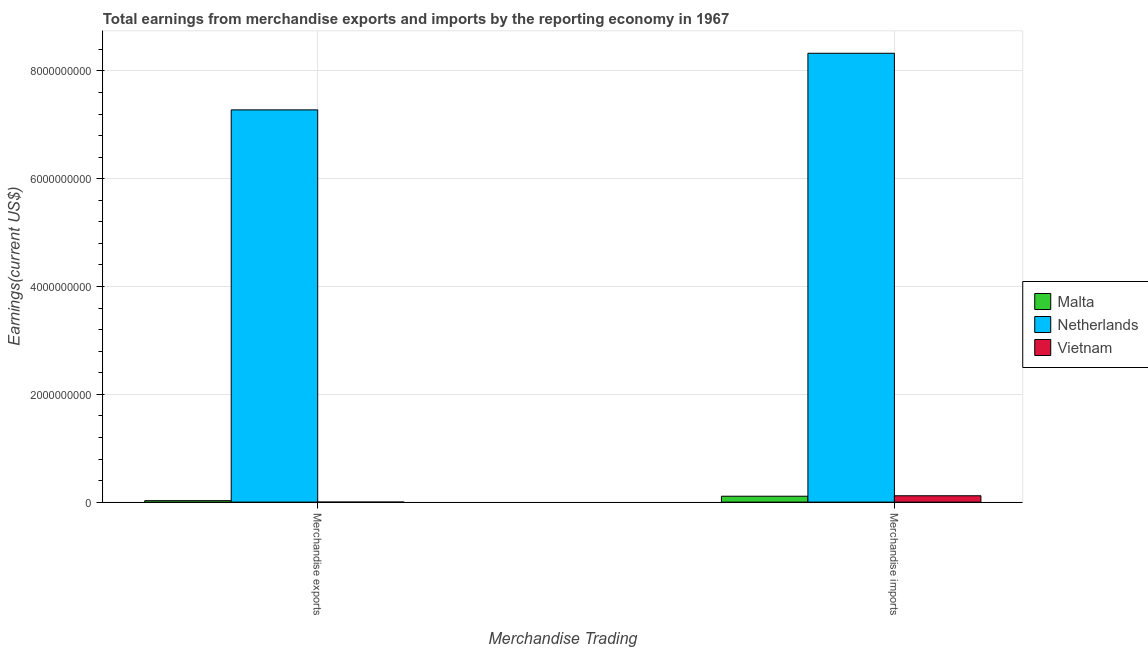How many different coloured bars are there?
Provide a short and direct response. 3. How many groups of bars are there?
Offer a very short reply. 2. Are the number of bars per tick equal to the number of legend labels?
Offer a terse response. Yes. How many bars are there on the 2nd tick from the left?
Keep it short and to the point. 3. What is the earnings from merchandise imports in Vietnam?
Give a very brief answer. 1.18e+08. Across all countries, what is the maximum earnings from merchandise exports?
Offer a very short reply. 7.28e+09. Across all countries, what is the minimum earnings from merchandise imports?
Make the answer very short. 1.10e+08. In which country was the earnings from merchandise imports maximum?
Your answer should be very brief. Netherlands. In which country was the earnings from merchandise imports minimum?
Provide a short and direct response. Malta. What is the total earnings from merchandise exports in the graph?
Keep it short and to the point. 7.31e+09. What is the difference between the earnings from merchandise exports in Malta and that in Netherlands?
Keep it short and to the point. -7.25e+09. What is the difference between the earnings from merchandise exports in Malta and the earnings from merchandise imports in Vietnam?
Provide a short and direct response. -9.09e+07. What is the average earnings from merchandise exports per country?
Provide a succinct answer. 2.44e+09. What is the difference between the earnings from merchandise exports and earnings from merchandise imports in Netherlands?
Your response must be concise. -1.05e+09. What is the ratio of the earnings from merchandise exports in Vietnam to that in Malta?
Your answer should be compact. 0.01. In how many countries, is the earnings from merchandise imports greater than the average earnings from merchandise imports taken over all countries?
Offer a terse response. 1. What does the 3rd bar from the left in Merchandise imports represents?
Ensure brevity in your answer.  Vietnam. What does the 1st bar from the right in Merchandise imports represents?
Your response must be concise. Vietnam. How many countries are there in the graph?
Offer a terse response. 3. What is the difference between two consecutive major ticks on the Y-axis?
Give a very brief answer. 2.00e+09. Are the values on the major ticks of Y-axis written in scientific E-notation?
Offer a very short reply. No. Does the graph contain grids?
Provide a short and direct response. Yes. How are the legend labels stacked?
Provide a short and direct response. Vertical. What is the title of the graph?
Offer a terse response. Total earnings from merchandise exports and imports by the reporting economy in 1967. What is the label or title of the X-axis?
Offer a very short reply. Merchandise Trading. What is the label or title of the Y-axis?
Your answer should be very brief. Earnings(current US$). What is the Earnings(current US$) of Malta in Merchandise exports?
Ensure brevity in your answer.  2.72e+07. What is the Earnings(current US$) in Netherlands in Merchandise exports?
Keep it short and to the point. 7.28e+09. What is the Earnings(current US$) in Vietnam in Merchandise exports?
Provide a succinct answer. 2.63e+05. What is the Earnings(current US$) of Malta in Merchandise imports?
Give a very brief answer. 1.10e+08. What is the Earnings(current US$) of Netherlands in Merchandise imports?
Keep it short and to the point. 8.33e+09. What is the Earnings(current US$) of Vietnam in Merchandise imports?
Give a very brief answer. 1.18e+08. Across all Merchandise Trading, what is the maximum Earnings(current US$) in Malta?
Ensure brevity in your answer.  1.10e+08. Across all Merchandise Trading, what is the maximum Earnings(current US$) of Netherlands?
Your answer should be compact. 8.33e+09. Across all Merchandise Trading, what is the maximum Earnings(current US$) in Vietnam?
Your answer should be very brief. 1.18e+08. Across all Merchandise Trading, what is the minimum Earnings(current US$) in Malta?
Give a very brief answer. 2.72e+07. Across all Merchandise Trading, what is the minimum Earnings(current US$) of Netherlands?
Your answer should be compact. 7.28e+09. Across all Merchandise Trading, what is the minimum Earnings(current US$) in Vietnam?
Your response must be concise. 2.63e+05. What is the total Earnings(current US$) of Malta in the graph?
Offer a terse response. 1.37e+08. What is the total Earnings(current US$) in Netherlands in the graph?
Your response must be concise. 1.56e+1. What is the total Earnings(current US$) of Vietnam in the graph?
Keep it short and to the point. 1.18e+08. What is the difference between the Earnings(current US$) of Malta in Merchandise exports and that in Merchandise imports?
Ensure brevity in your answer.  -8.24e+07. What is the difference between the Earnings(current US$) of Netherlands in Merchandise exports and that in Merchandise imports?
Ensure brevity in your answer.  -1.05e+09. What is the difference between the Earnings(current US$) in Vietnam in Merchandise exports and that in Merchandise imports?
Offer a terse response. -1.18e+08. What is the difference between the Earnings(current US$) of Malta in Merchandise exports and the Earnings(current US$) of Netherlands in Merchandise imports?
Keep it short and to the point. -8.30e+09. What is the difference between the Earnings(current US$) of Malta in Merchandise exports and the Earnings(current US$) of Vietnam in Merchandise imports?
Ensure brevity in your answer.  -9.09e+07. What is the difference between the Earnings(current US$) in Netherlands in Merchandise exports and the Earnings(current US$) in Vietnam in Merchandise imports?
Make the answer very short. 7.16e+09. What is the average Earnings(current US$) in Malta per Merchandise Trading?
Keep it short and to the point. 6.83e+07. What is the average Earnings(current US$) of Netherlands per Merchandise Trading?
Your answer should be very brief. 7.80e+09. What is the average Earnings(current US$) of Vietnam per Merchandise Trading?
Offer a terse response. 5.92e+07. What is the difference between the Earnings(current US$) in Malta and Earnings(current US$) in Netherlands in Merchandise exports?
Provide a short and direct response. -7.25e+09. What is the difference between the Earnings(current US$) in Malta and Earnings(current US$) in Vietnam in Merchandise exports?
Your response must be concise. 2.69e+07. What is the difference between the Earnings(current US$) of Netherlands and Earnings(current US$) of Vietnam in Merchandise exports?
Your answer should be compact. 7.28e+09. What is the difference between the Earnings(current US$) in Malta and Earnings(current US$) in Netherlands in Merchandise imports?
Provide a succinct answer. -8.22e+09. What is the difference between the Earnings(current US$) in Malta and Earnings(current US$) in Vietnam in Merchandise imports?
Provide a short and direct response. -8.51e+06. What is the difference between the Earnings(current US$) in Netherlands and Earnings(current US$) in Vietnam in Merchandise imports?
Provide a short and direct response. 8.21e+09. What is the ratio of the Earnings(current US$) of Malta in Merchandise exports to that in Merchandise imports?
Give a very brief answer. 0.25. What is the ratio of the Earnings(current US$) of Netherlands in Merchandise exports to that in Merchandise imports?
Give a very brief answer. 0.87. What is the ratio of the Earnings(current US$) in Vietnam in Merchandise exports to that in Merchandise imports?
Your answer should be very brief. 0. What is the difference between the highest and the second highest Earnings(current US$) of Malta?
Provide a short and direct response. 8.24e+07. What is the difference between the highest and the second highest Earnings(current US$) in Netherlands?
Keep it short and to the point. 1.05e+09. What is the difference between the highest and the second highest Earnings(current US$) of Vietnam?
Give a very brief answer. 1.18e+08. What is the difference between the highest and the lowest Earnings(current US$) in Malta?
Give a very brief answer. 8.24e+07. What is the difference between the highest and the lowest Earnings(current US$) of Netherlands?
Ensure brevity in your answer.  1.05e+09. What is the difference between the highest and the lowest Earnings(current US$) of Vietnam?
Offer a terse response. 1.18e+08. 